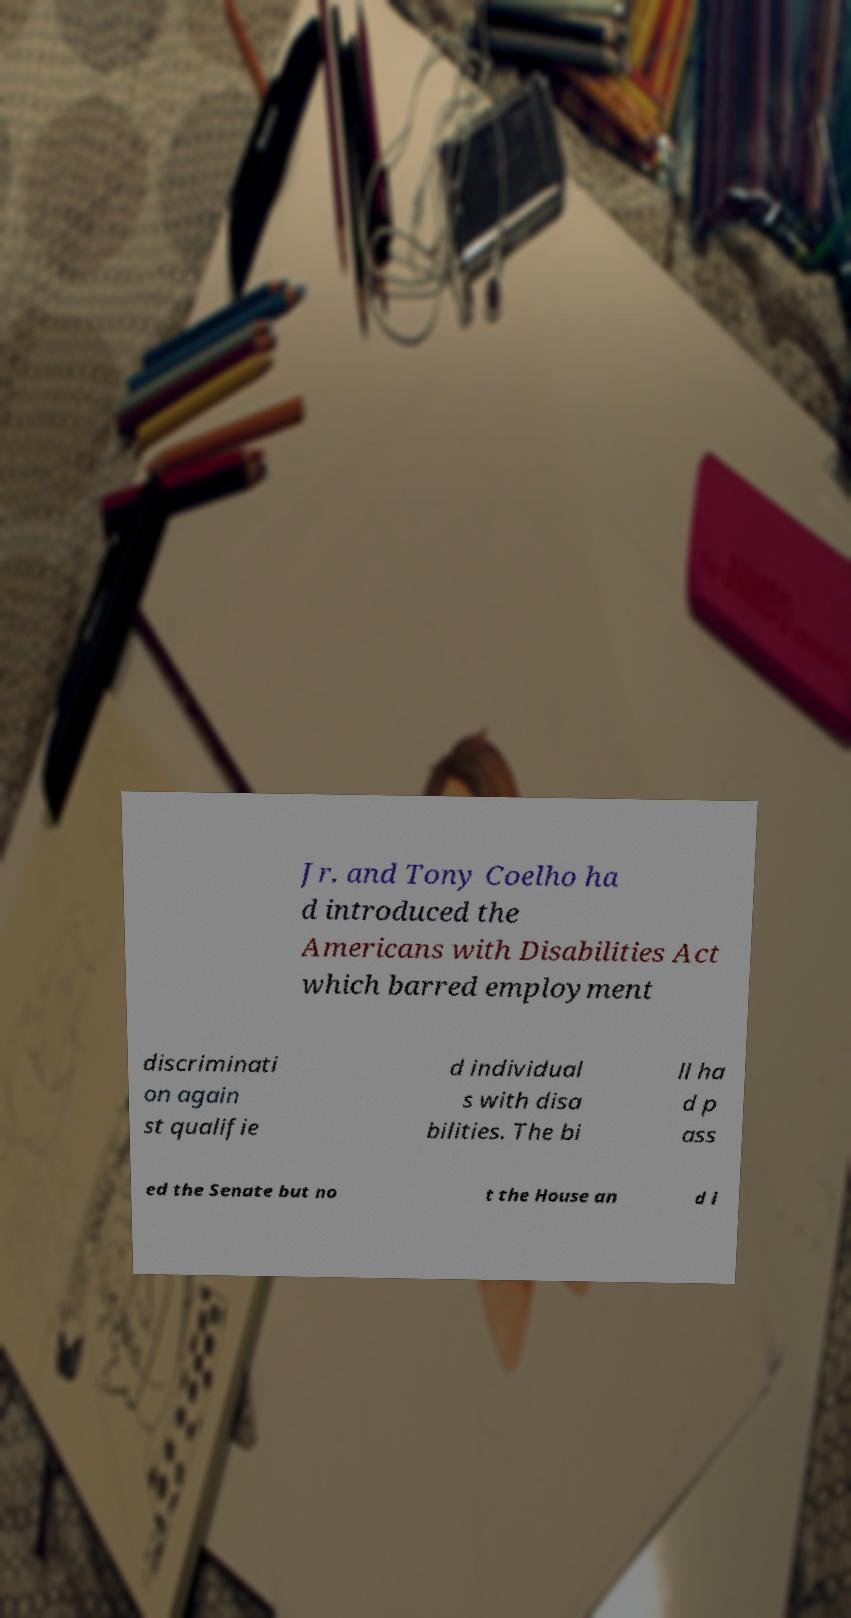What messages or text are displayed in this image? I need them in a readable, typed format. Jr. and Tony Coelho ha d introduced the Americans with Disabilities Act which barred employment discriminati on again st qualifie d individual s with disa bilities. The bi ll ha d p ass ed the Senate but no t the House an d i 